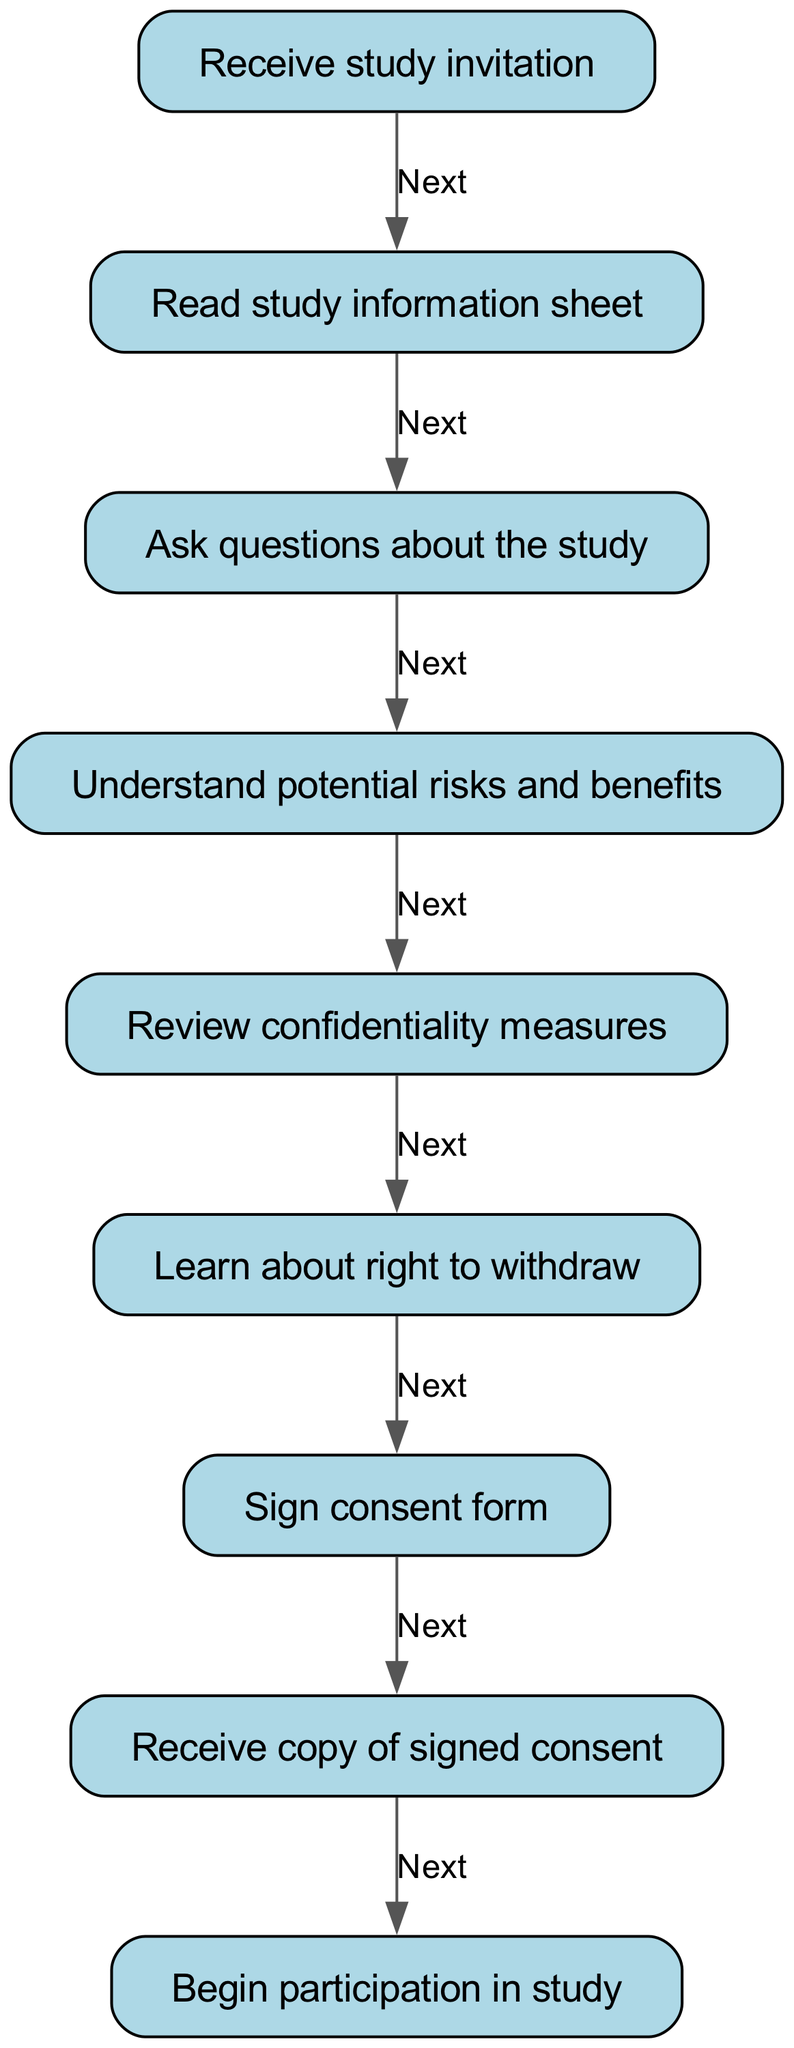What is the first step in the informed consent process? The diagram starts with the first node labeled "Receive study invitation," which indicates the initial step that participants are required to take in the informed consent process.
Answer: Receive study invitation How many total steps are there in the consent process? Counting all the nodes in the diagram, there are nine distinct steps from receiving the study invitation to beginning participation, showing the entire flow of the consent process.
Answer: Nine What does the node after "Ask questions about the study" represent? Following the "Ask questions about the study" node, the next step indicated in the diagram is "Understand potential risks and benefits," which outlines the necessary informative step regarding risks and benefits.
Answer: Understand potential risks and benefits What is the last action in the consent process? The final node before participation in the study is labeled "Receive copy of signed consent," indicating that participants should receive documentation of their consent as the last action in the process.
Answer: Receive copy of signed consent Which step includes information about right to withdraw? The right to withdraw from the study is covered in the step labeled "Learn about right to withdraw," which comes after reviewing confidentiality measures and before signing the consent form.
Answer: Learn about right to withdraw What step follows "Sign consent form"? After the participants "Sign consent form," they move on to the next step, which is "Receive copy of signed consent," indicating that they will receive a copy of the signed document immediately after consenting.
Answer: Receive copy of signed consent In which step is it mandatory to ask questions? It is mandatory to ask questions in the step labeled "Ask questions about the study," where participants are encouraged to clarify any doubts they may have before proceeding further.
Answer: Ask questions about the study What are participants informed about in step five? In step five, "Review confidentiality measures," participants are informed about how their data will be kept confidential, ensuring their privacy during the research study.
Answer: Review confidentiality measures 